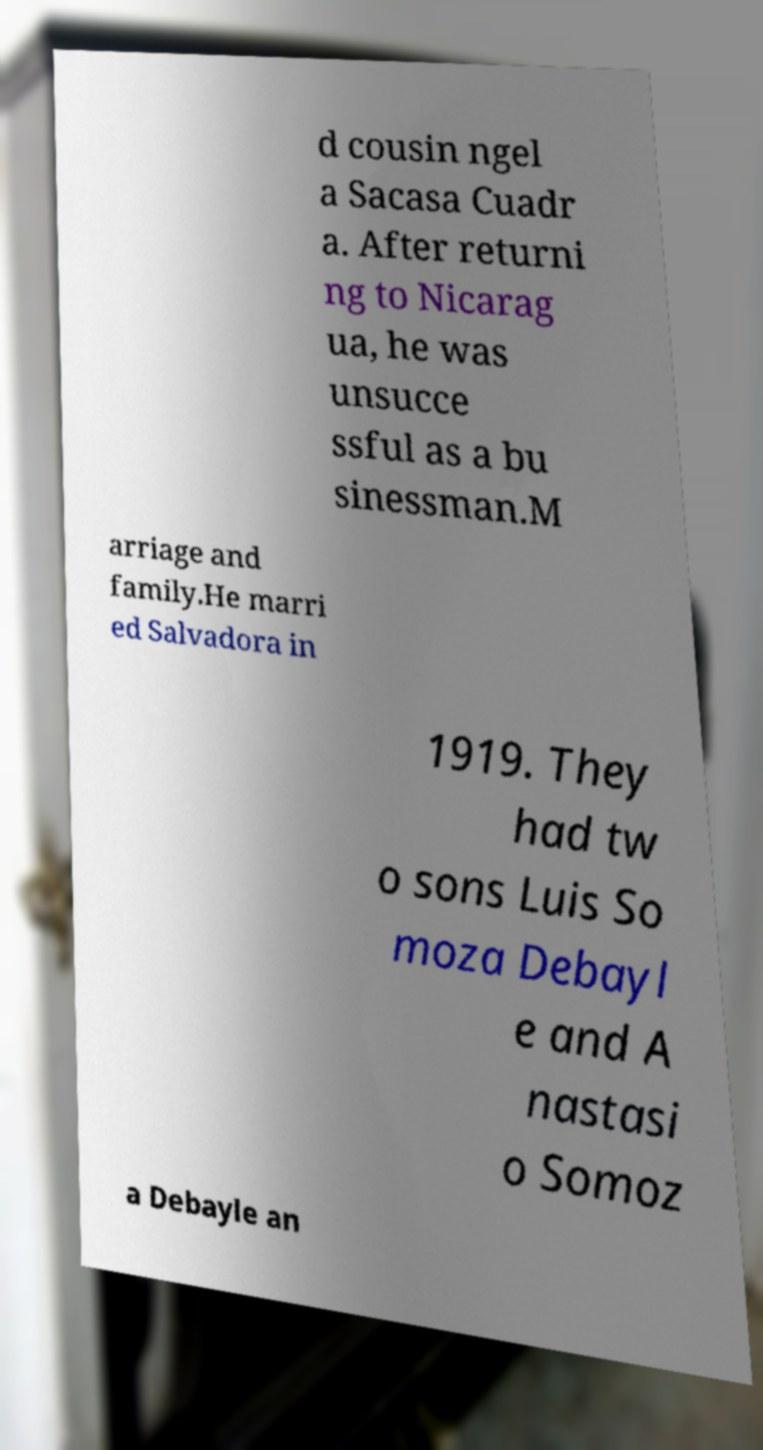Please read and relay the text visible in this image. What does it say? d cousin ngel a Sacasa Cuadr a. After returni ng to Nicarag ua, he was unsucce ssful as a bu sinessman.M arriage and family.He marri ed Salvadora in 1919. They had tw o sons Luis So moza Debayl e and A nastasi o Somoz a Debayle an 